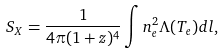Convert formula to latex. <formula><loc_0><loc_0><loc_500><loc_500>S _ { X } = \frac { 1 } { 4 \pi ( 1 + z ) ^ { 4 } } \int n _ { e } ^ { 2 } \Lambda ( T _ { e } ) d l ,</formula> 